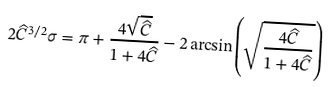<formula> <loc_0><loc_0><loc_500><loc_500>2 \widehat { C } ^ { 3 / 2 } \sigma = \pi + \frac { 4 \sqrt { \widehat { C } } } { 1 + 4 \widehat { C } } - 2 \arcsin \left ( \sqrt { \frac { 4 \widehat { C } } { 1 + 4 \widehat { C } } } \right )</formula> 